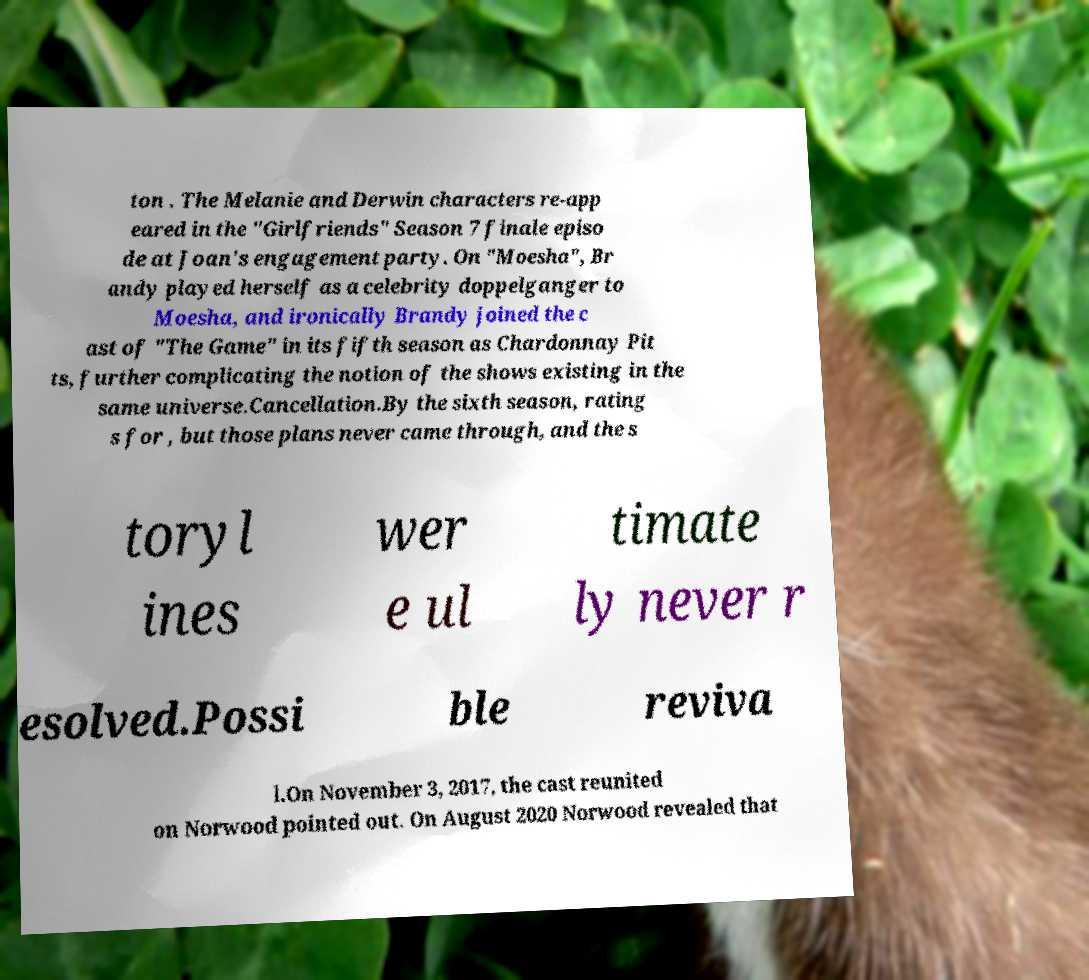What messages or text are displayed in this image? I need them in a readable, typed format. ton . The Melanie and Derwin characters re-app eared in the "Girlfriends" Season 7 finale episo de at Joan's engagement party. On "Moesha", Br andy played herself as a celebrity doppelganger to Moesha, and ironically Brandy joined the c ast of "The Game" in its fifth season as Chardonnay Pit ts, further complicating the notion of the shows existing in the same universe.Cancellation.By the sixth season, rating s for , but those plans never came through, and the s toryl ines wer e ul timate ly never r esolved.Possi ble reviva l.On November 3, 2017, the cast reunited on Norwood pointed out. On August 2020 Norwood revealed that 